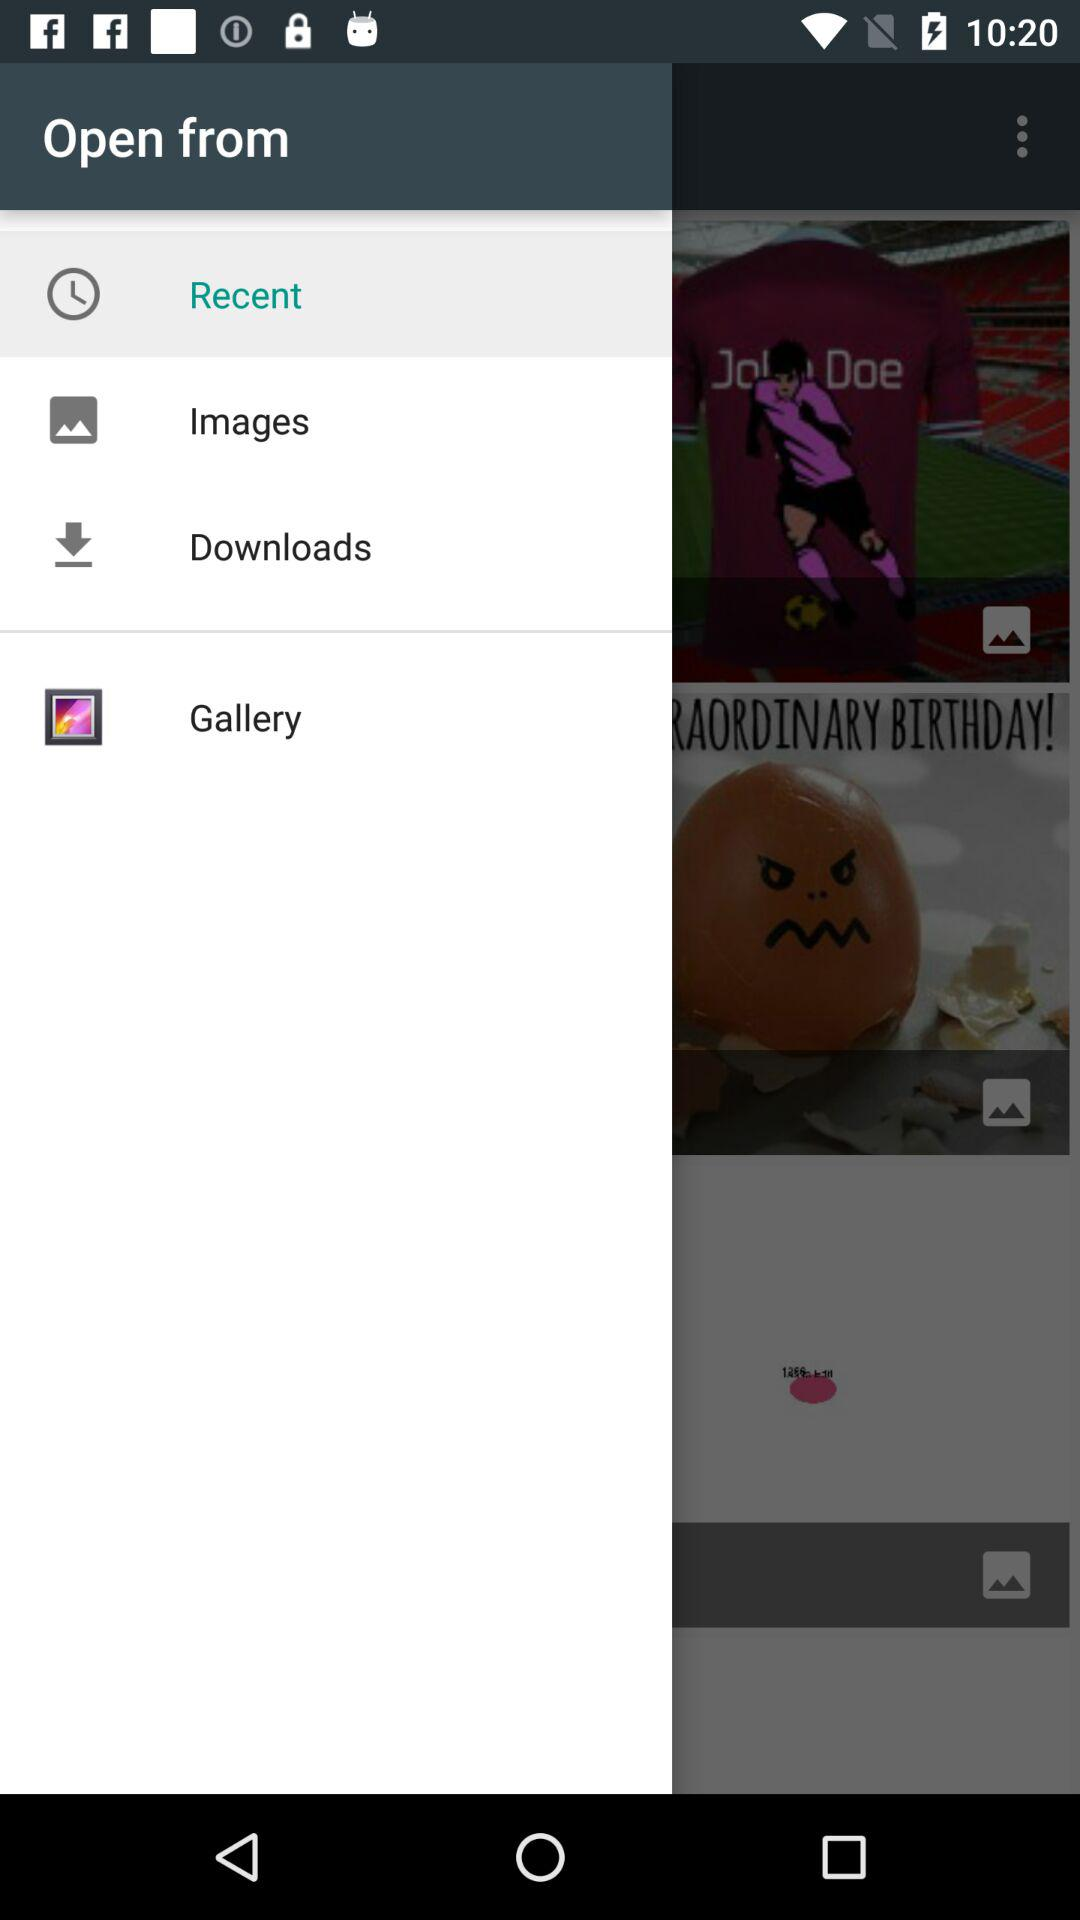How many items are downloaded?
When the provided information is insufficient, respond with <no answer>. <no answer> 